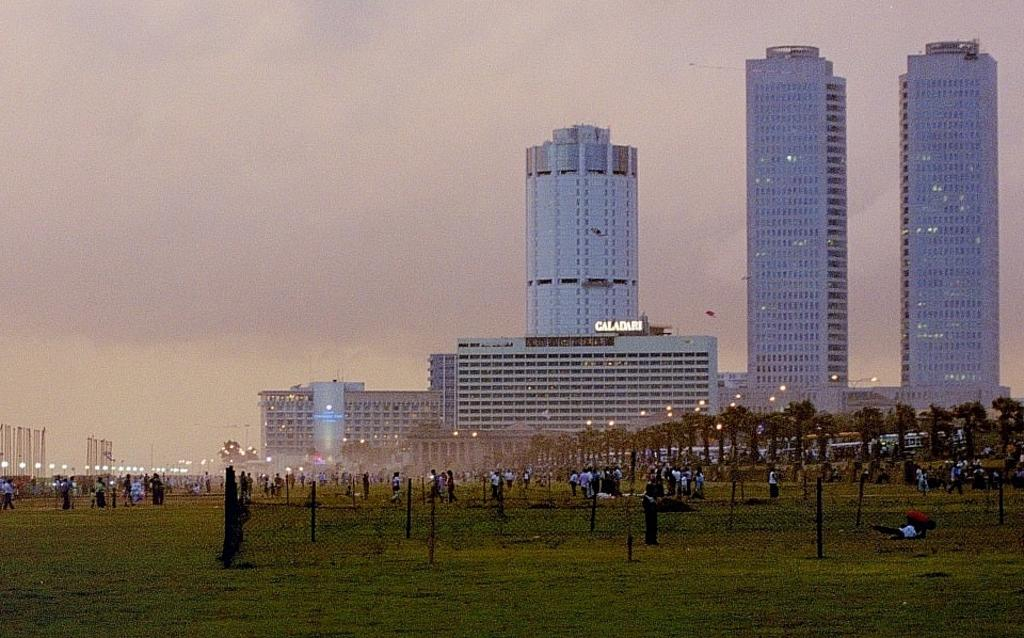What are the people in the image doing? The people in the image are walking on the grass surface. What objects are around the people? There are wooden sticks around the people. What can be seen in the background of the image? There are lamp posts, trees, and buildings in the background of the image. What type of books can be seen in the library in the image? There is no library present in the image, so it is not possible to determine what type of books might be seen. 